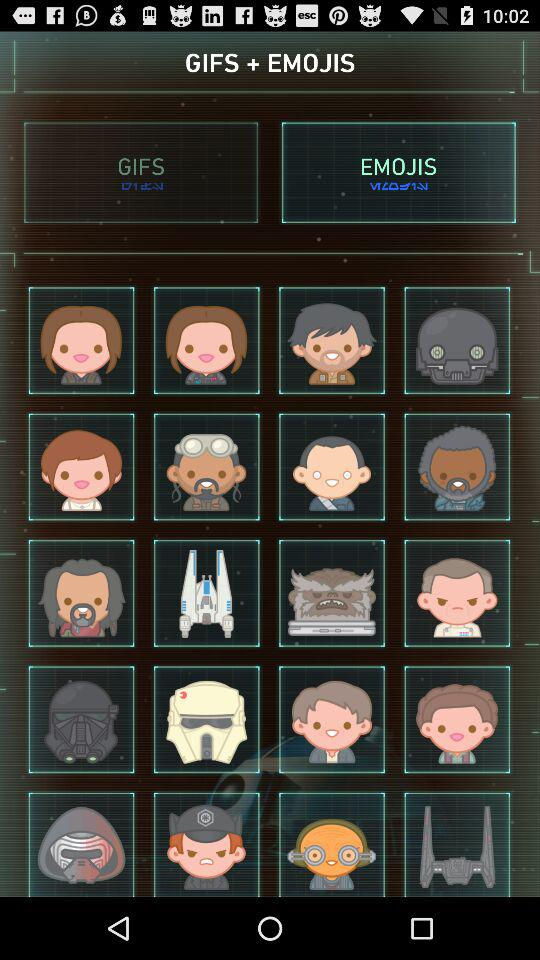How many emojis are selected?
When the provided information is insufficient, respond with <no answer>. <no answer> 